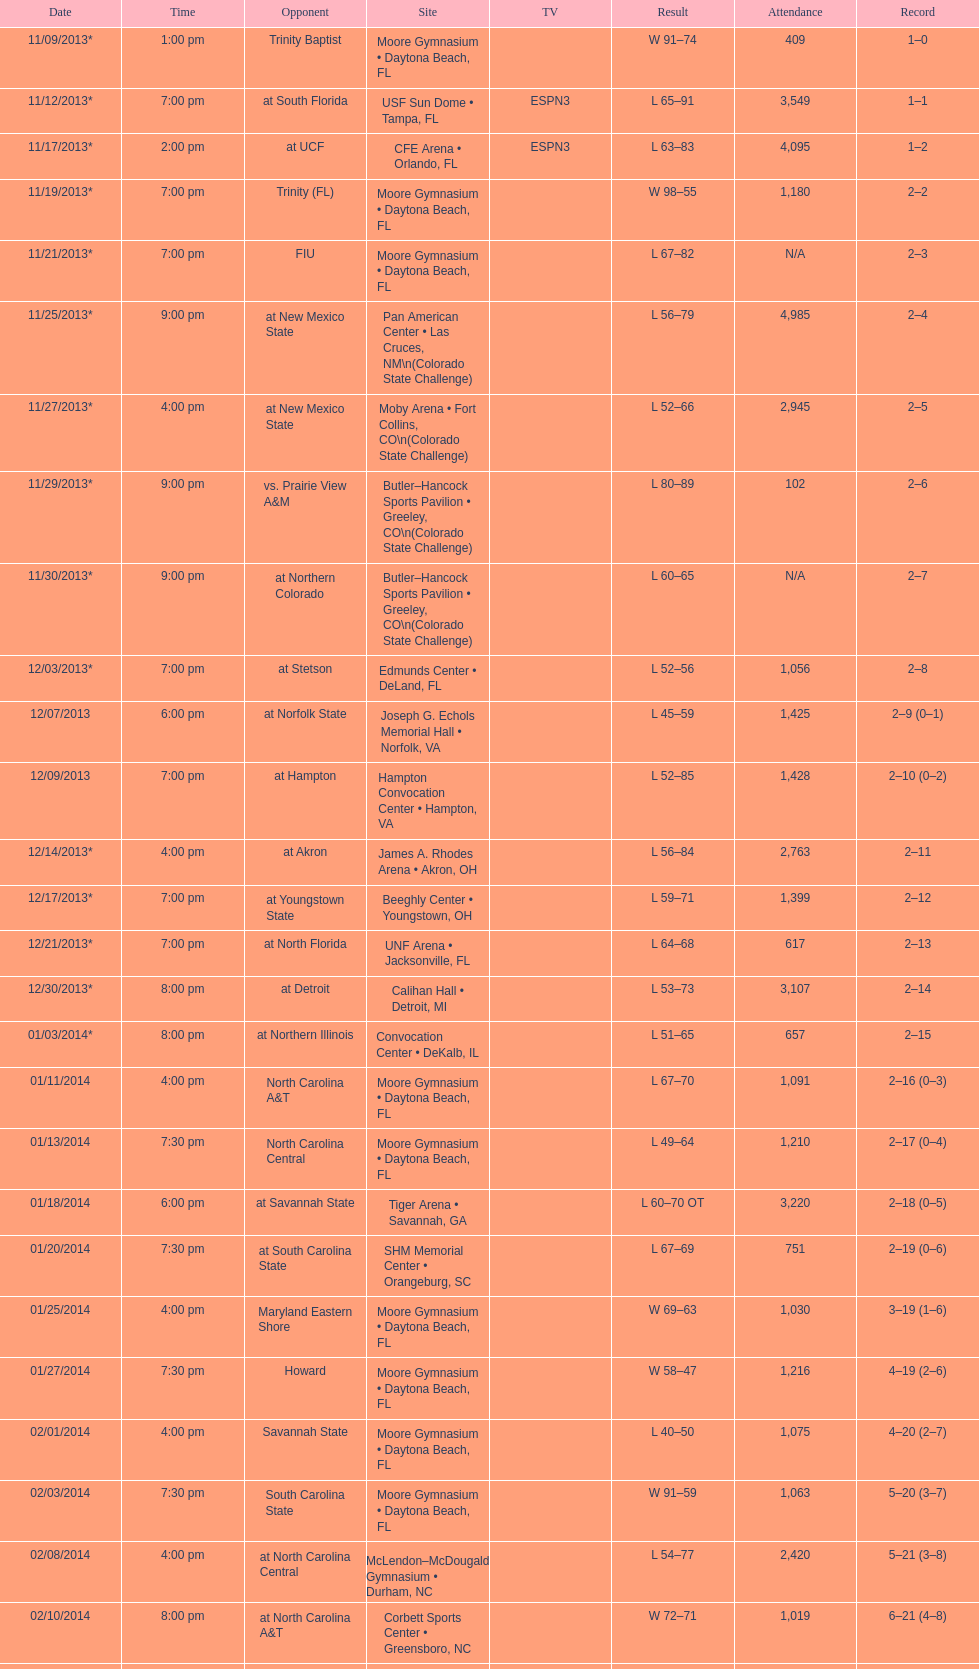What was the overall number of attendees on november 9, 2013? 409. 